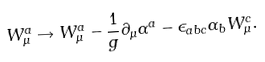Convert formula to latex. <formula><loc_0><loc_0><loc_500><loc_500>W ^ { a } _ { \mu } \rightarrow W ^ { a } _ { \mu } - \frac { 1 } { g } \partial _ { \mu } \alpha ^ { a } - \epsilon _ { a b c } \alpha _ { b } W ^ { c } _ { \mu } .</formula> 